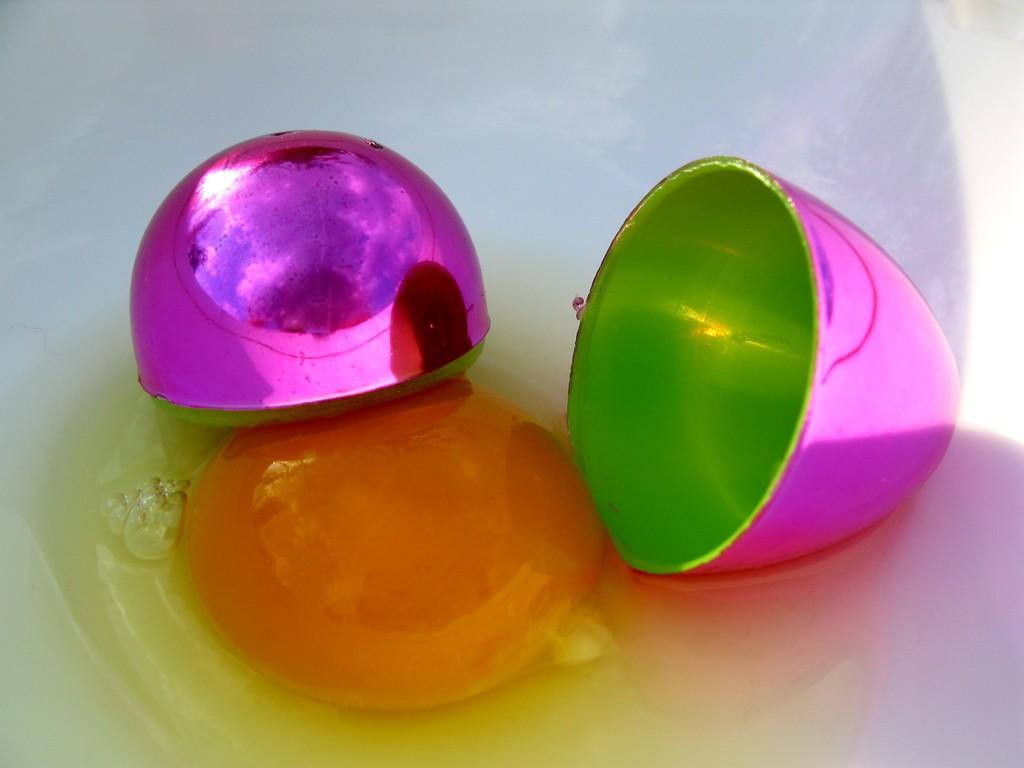What color is the bowl in the image? The bowl in the image is white-colored. What is inside the bowl? The bowl contains egg white and yolk. What other egg-related item is present in the image? There is a plastic egg in the image. What colors are used for the plastic egg? The plastic egg is pink and green in color. What type of account does the egg offer in the image? There is no account or offer mentioned in the image; it features a white-colored bowl with egg white and yolk, along with a pink and green plastic egg. 